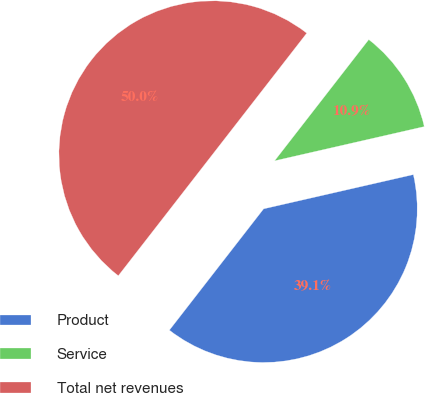<chart> <loc_0><loc_0><loc_500><loc_500><pie_chart><fcel>Product<fcel>Service<fcel>Total net revenues<nl><fcel>39.09%<fcel>10.91%<fcel>50.0%<nl></chart> 